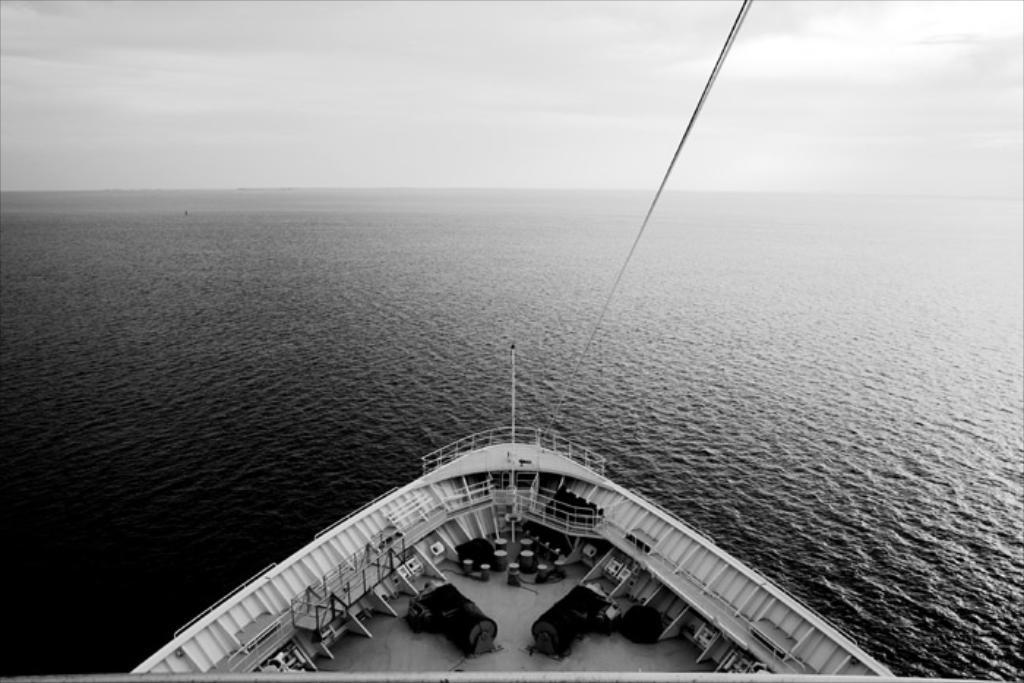What is the main subject in the foreground of the image? There is a deck of a ship in the foreground of the image. What can be seen in the middle of the image? There is a water body in the middle of the image. What is visible at the top of the image? The sky is visible at the top of the image. How many pears are hanging from the ship's railing in the image? There are no pears present in the image; it features a deck of a ship, a water body, and the sky. 